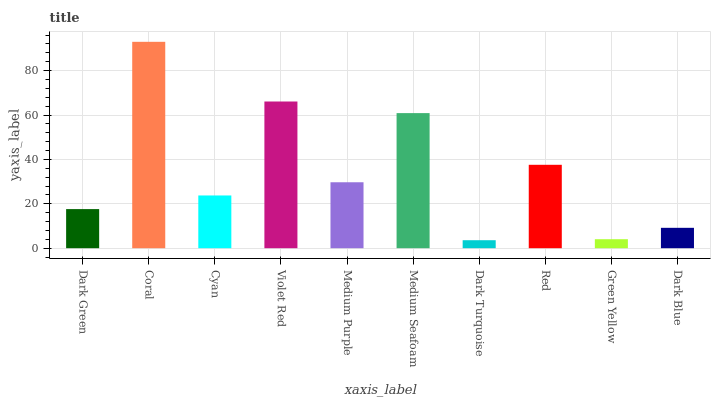Is Dark Turquoise the minimum?
Answer yes or no. Yes. Is Coral the maximum?
Answer yes or no. Yes. Is Cyan the minimum?
Answer yes or no. No. Is Cyan the maximum?
Answer yes or no. No. Is Coral greater than Cyan?
Answer yes or no. Yes. Is Cyan less than Coral?
Answer yes or no. Yes. Is Cyan greater than Coral?
Answer yes or no. No. Is Coral less than Cyan?
Answer yes or no. No. Is Medium Purple the high median?
Answer yes or no. Yes. Is Cyan the low median?
Answer yes or no. Yes. Is Dark Green the high median?
Answer yes or no. No. Is Dark Green the low median?
Answer yes or no. No. 